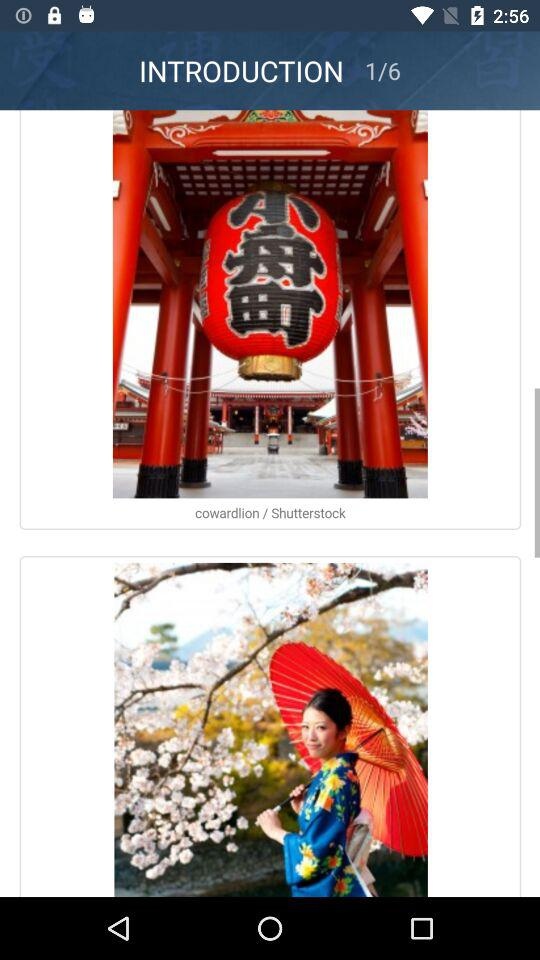How many images in total are there? There are 6 images. 